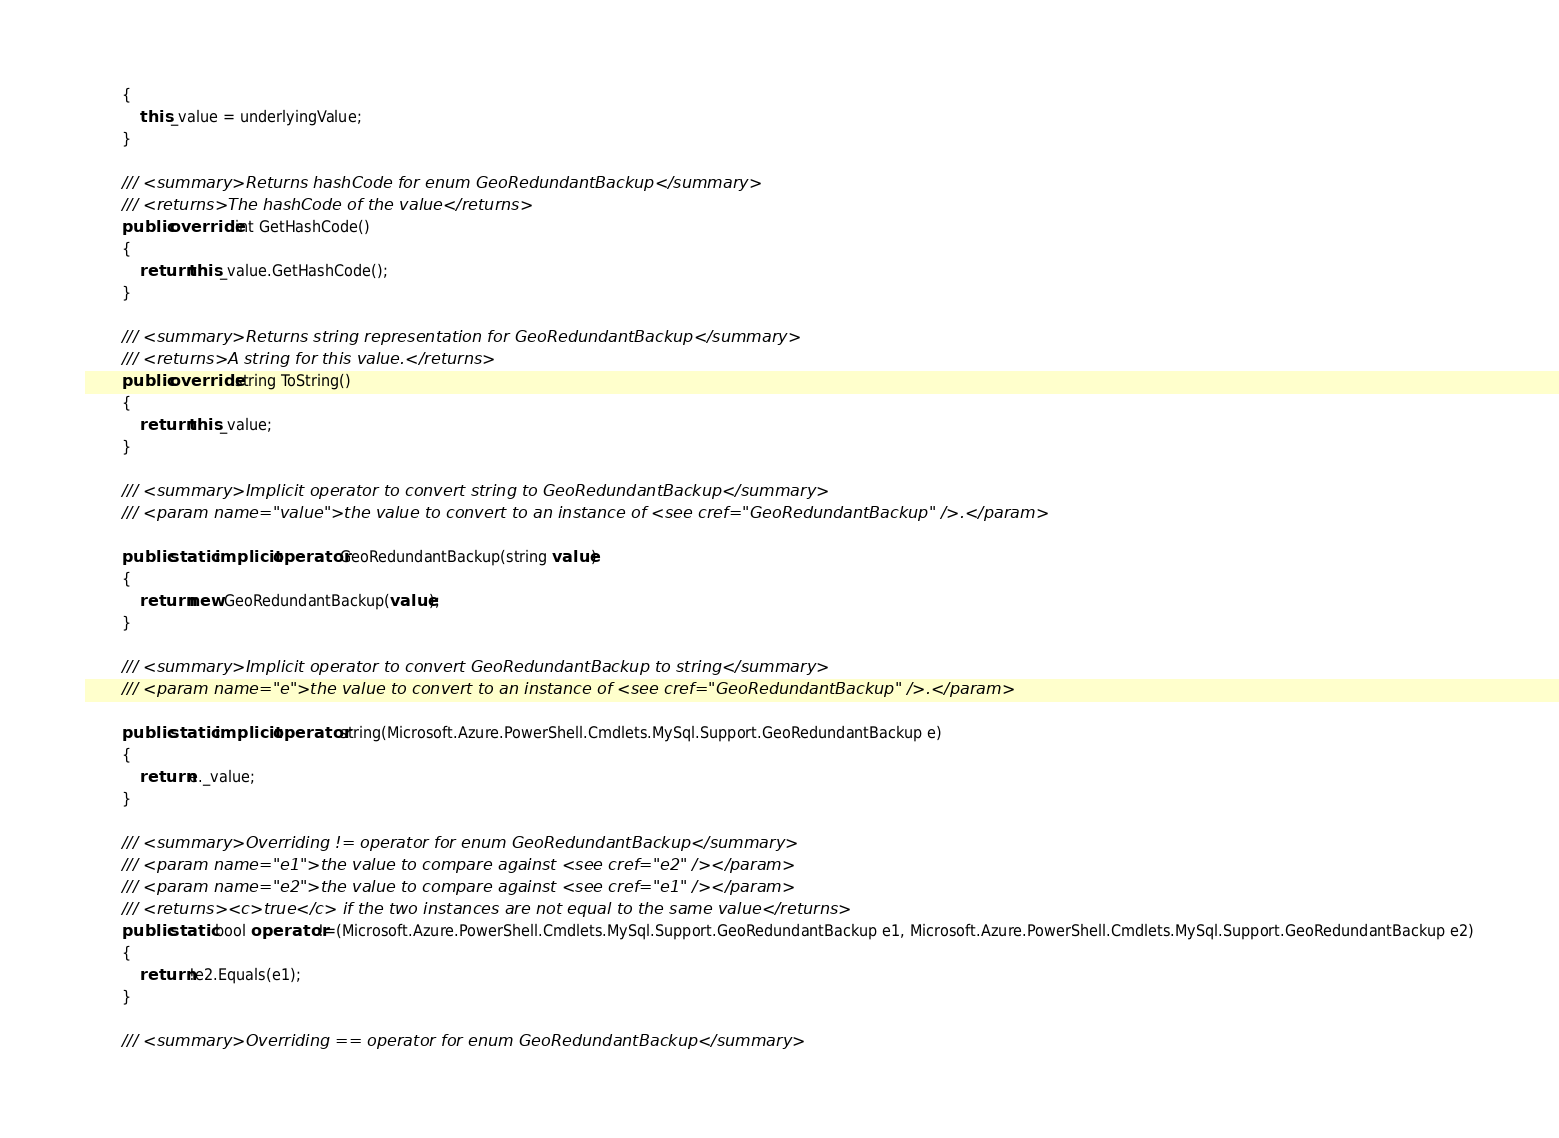<code> <loc_0><loc_0><loc_500><loc_500><_C#_>        {
            this._value = underlyingValue;
        }

        /// <summary>Returns hashCode for enum GeoRedundantBackup</summary>
        /// <returns>The hashCode of the value</returns>
        public override int GetHashCode()
        {
            return this._value.GetHashCode();
        }

        /// <summary>Returns string representation for GeoRedundantBackup</summary>
        /// <returns>A string for this value.</returns>
        public override string ToString()
        {
            return this._value;
        }

        /// <summary>Implicit operator to convert string to GeoRedundantBackup</summary>
        /// <param name="value">the value to convert to an instance of <see cref="GeoRedundantBackup" />.</param>

        public static implicit operator GeoRedundantBackup(string value)
        {
            return new GeoRedundantBackup(value);
        }

        /// <summary>Implicit operator to convert GeoRedundantBackup to string</summary>
        /// <param name="e">the value to convert to an instance of <see cref="GeoRedundantBackup" />.</param>

        public static implicit operator string(Microsoft.Azure.PowerShell.Cmdlets.MySql.Support.GeoRedundantBackup e)
        {
            return e._value;
        }

        /// <summary>Overriding != operator for enum GeoRedundantBackup</summary>
        /// <param name="e1">the value to compare against <see cref="e2" /></param>
        /// <param name="e2">the value to compare against <see cref="e1" /></param>
        /// <returns><c>true</c> if the two instances are not equal to the same value</returns>
        public static bool operator !=(Microsoft.Azure.PowerShell.Cmdlets.MySql.Support.GeoRedundantBackup e1, Microsoft.Azure.PowerShell.Cmdlets.MySql.Support.GeoRedundantBackup e2)
        {
            return !e2.Equals(e1);
        }

        /// <summary>Overriding == operator for enum GeoRedundantBackup</summary></code> 